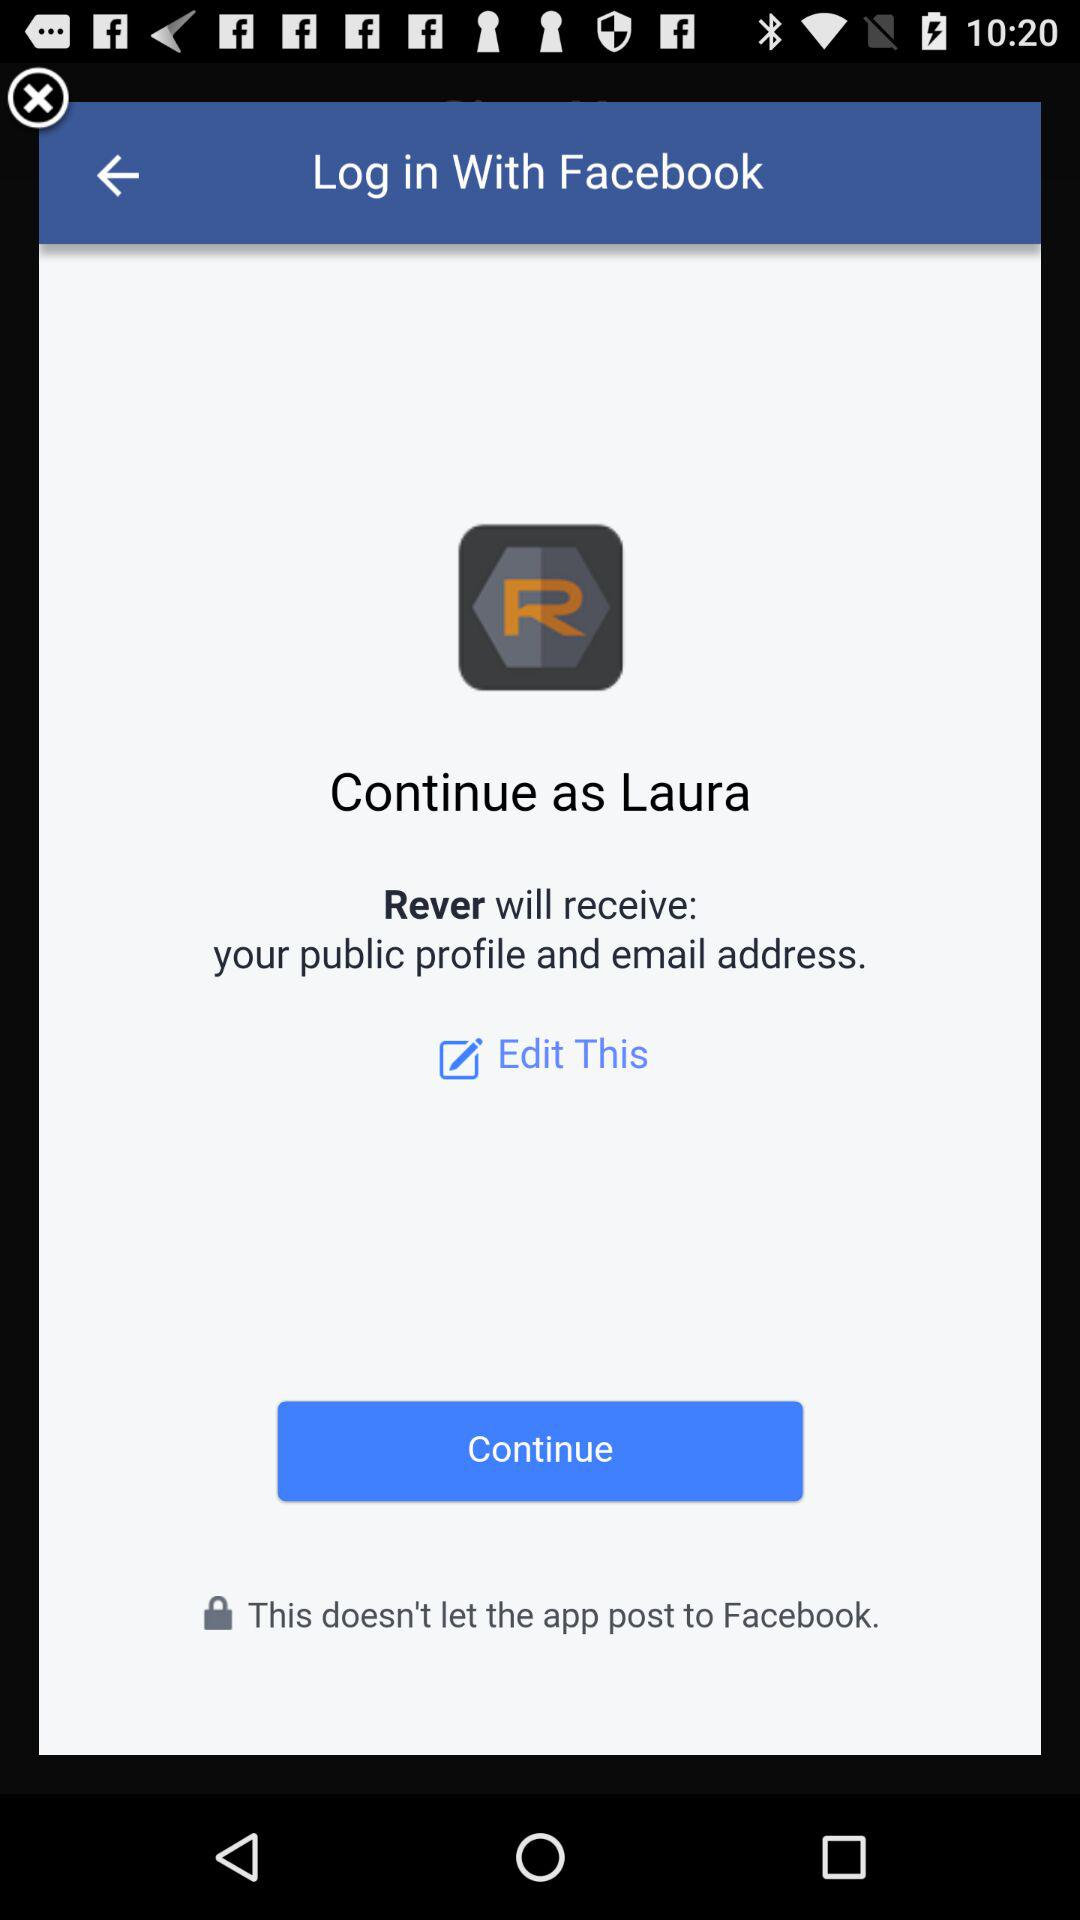What application will receive your public profile and email address? The application that will receive your public profile and email address is "Rever". 